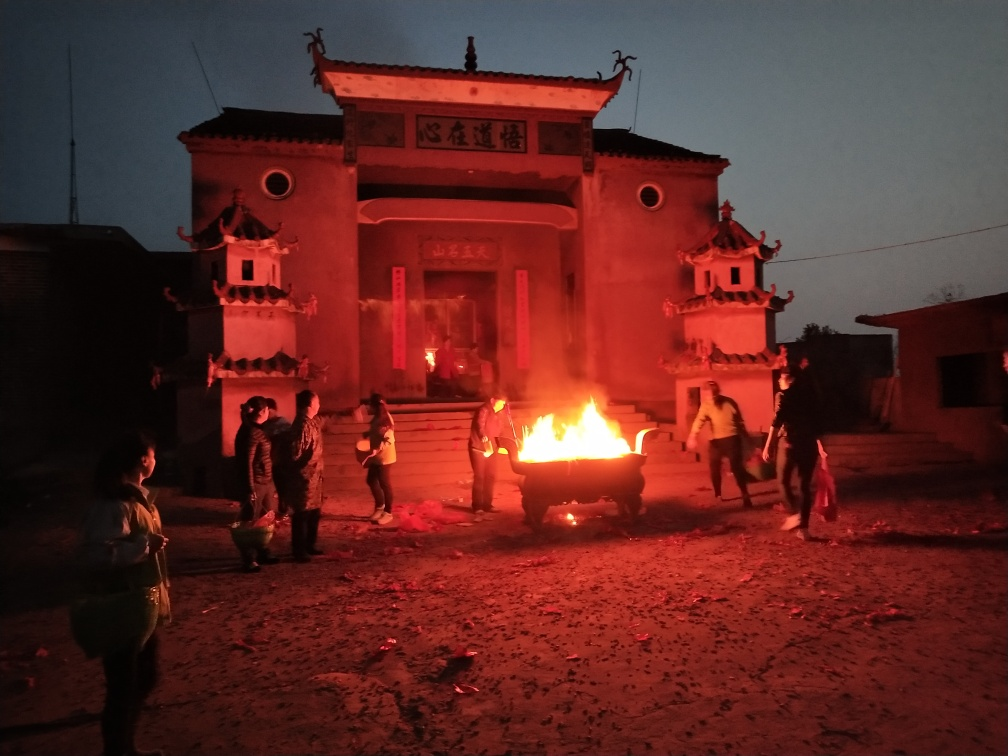What can you infer about the cultural significance of the activities shown in this image? The image suggests that the people are participating in a cultural or traditional event. The focal point is the fire, which might be part of a ritual or celebration. The setting in front of the building adorned with architectural details indicates a place of importance, possibly a temple or community hall, which may add to the ceremonial value of the event. 